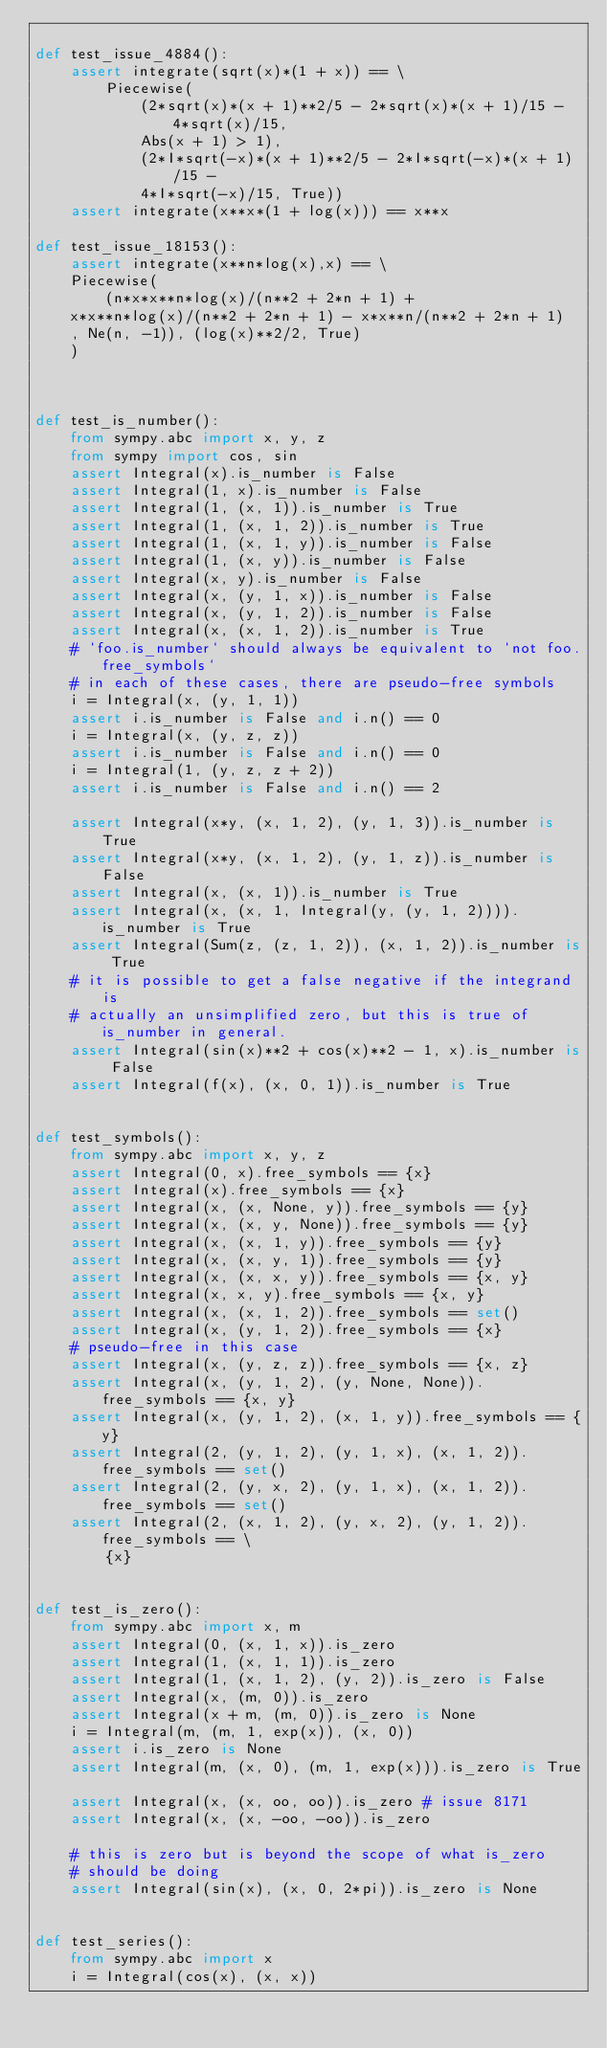Convert code to text. <code><loc_0><loc_0><loc_500><loc_500><_Python_>
def test_issue_4884():
    assert integrate(sqrt(x)*(1 + x)) == \
        Piecewise(
            (2*sqrt(x)*(x + 1)**2/5 - 2*sqrt(x)*(x + 1)/15 - 4*sqrt(x)/15,
            Abs(x + 1) > 1),
            (2*I*sqrt(-x)*(x + 1)**2/5 - 2*I*sqrt(-x)*(x + 1)/15 -
            4*I*sqrt(-x)/15, True))
    assert integrate(x**x*(1 + log(x))) == x**x

def test_issue_18153():
    assert integrate(x**n*log(x),x) == \
    Piecewise(
        (n*x*x**n*log(x)/(n**2 + 2*n + 1) +
    x*x**n*log(x)/(n**2 + 2*n + 1) - x*x**n/(n**2 + 2*n + 1)
    , Ne(n, -1)), (log(x)**2/2, True)
    )



def test_is_number():
    from sympy.abc import x, y, z
    from sympy import cos, sin
    assert Integral(x).is_number is False
    assert Integral(1, x).is_number is False
    assert Integral(1, (x, 1)).is_number is True
    assert Integral(1, (x, 1, 2)).is_number is True
    assert Integral(1, (x, 1, y)).is_number is False
    assert Integral(1, (x, y)).is_number is False
    assert Integral(x, y).is_number is False
    assert Integral(x, (y, 1, x)).is_number is False
    assert Integral(x, (y, 1, 2)).is_number is False
    assert Integral(x, (x, 1, 2)).is_number is True
    # `foo.is_number` should always be equivalent to `not foo.free_symbols`
    # in each of these cases, there are pseudo-free symbols
    i = Integral(x, (y, 1, 1))
    assert i.is_number is False and i.n() == 0
    i = Integral(x, (y, z, z))
    assert i.is_number is False and i.n() == 0
    i = Integral(1, (y, z, z + 2))
    assert i.is_number is False and i.n() == 2

    assert Integral(x*y, (x, 1, 2), (y, 1, 3)).is_number is True
    assert Integral(x*y, (x, 1, 2), (y, 1, z)).is_number is False
    assert Integral(x, (x, 1)).is_number is True
    assert Integral(x, (x, 1, Integral(y, (y, 1, 2)))).is_number is True
    assert Integral(Sum(z, (z, 1, 2)), (x, 1, 2)).is_number is True
    # it is possible to get a false negative if the integrand is
    # actually an unsimplified zero, but this is true of is_number in general.
    assert Integral(sin(x)**2 + cos(x)**2 - 1, x).is_number is False
    assert Integral(f(x), (x, 0, 1)).is_number is True


def test_symbols():
    from sympy.abc import x, y, z
    assert Integral(0, x).free_symbols == {x}
    assert Integral(x).free_symbols == {x}
    assert Integral(x, (x, None, y)).free_symbols == {y}
    assert Integral(x, (x, y, None)).free_symbols == {y}
    assert Integral(x, (x, 1, y)).free_symbols == {y}
    assert Integral(x, (x, y, 1)).free_symbols == {y}
    assert Integral(x, (x, x, y)).free_symbols == {x, y}
    assert Integral(x, x, y).free_symbols == {x, y}
    assert Integral(x, (x, 1, 2)).free_symbols == set()
    assert Integral(x, (y, 1, 2)).free_symbols == {x}
    # pseudo-free in this case
    assert Integral(x, (y, z, z)).free_symbols == {x, z}
    assert Integral(x, (y, 1, 2), (y, None, None)).free_symbols == {x, y}
    assert Integral(x, (y, 1, 2), (x, 1, y)).free_symbols == {y}
    assert Integral(2, (y, 1, 2), (y, 1, x), (x, 1, 2)).free_symbols == set()
    assert Integral(2, (y, x, 2), (y, 1, x), (x, 1, 2)).free_symbols == set()
    assert Integral(2, (x, 1, 2), (y, x, 2), (y, 1, 2)).free_symbols == \
        {x}


def test_is_zero():
    from sympy.abc import x, m
    assert Integral(0, (x, 1, x)).is_zero
    assert Integral(1, (x, 1, 1)).is_zero
    assert Integral(1, (x, 1, 2), (y, 2)).is_zero is False
    assert Integral(x, (m, 0)).is_zero
    assert Integral(x + m, (m, 0)).is_zero is None
    i = Integral(m, (m, 1, exp(x)), (x, 0))
    assert i.is_zero is None
    assert Integral(m, (x, 0), (m, 1, exp(x))).is_zero is True

    assert Integral(x, (x, oo, oo)).is_zero # issue 8171
    assert Integral(x, (x, -oo, -oo)).is_zero

    # this is zero but is beyond the scope of what is_zero
    # should be doing
    assert Integral(sin(x), (x, 0, 2*pi)).is_zero is None


def test_series():
    from sympy.abc import x
    i = Integral(cos(x), (x, x))</code> 